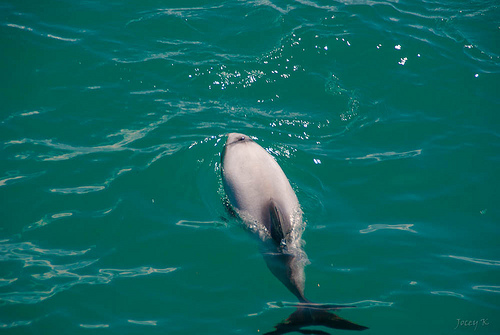<image>
Can you confirm if the water is on the fish? Yes. Looking at the image, I can see the water is positioned on top of the fish, with the fish providing support. 